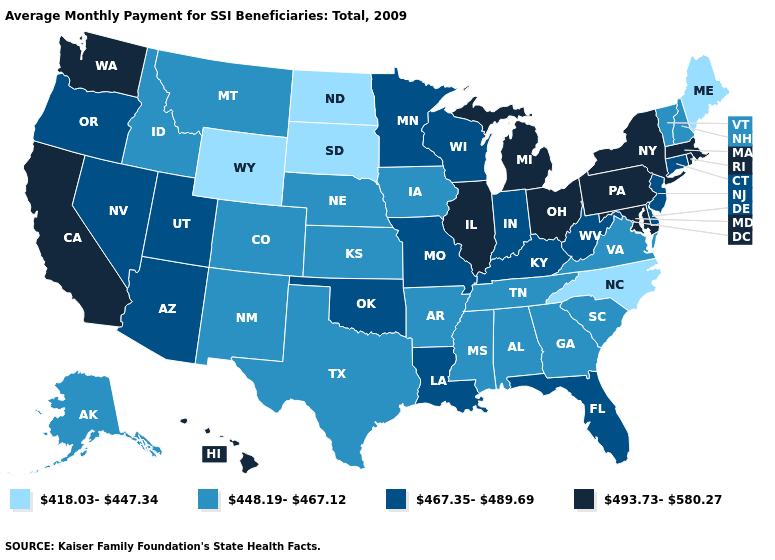Name the states that have a value in the range 418.03-447.34?
Give a very brief answer. Maine, North Carolina, North Dakota, South Dakota, Wyoming. Name the states that have a value in the range 448.19-467.12?
Answer briefly. Alabama, Alaska, Arkansas, Colorado, Georgia, Idaho, Iowa, Kansas, Mississippi, Montana, Nebraska, New Hampshire, New Mexico, South Carolina, Tennessee, Texas, Vermont, Virginia. What is the value of Maine?
Keep it brief. 418.03-447.34. What is the value of Alaska?
Quick response, please. 448.19-467.12. Among the states that border Arkansas , which have the lowest value?
Be succinct. Mississippi, Tennessee, Texas. Does the map have missing data?
Be succinct. No. Name the states that have a value in the range 493.73-580.27?
Give a very brief answer. California, Hawaii, Illinois, Maryland, Massachusetts, Michigan, New York, Ohio, Pennsylvania, Rhode Island, Washington. Name the states that have a value in the range 448.19-467.12?
Concise answer only. Alabama, Alaska, Arkansas, Colorado, Georgia, Idaho, Iowa, Kansas, Mississippi, Montana, Nebraska, New Hampshire, New Mexico, South Carolina, Tennessee, Texas, Vermont, Virginia. What is the value of Tennessee?
Be succinct. 448.19-467.12. Does Oklahoma have the same value as Minnesota?
Write a very short answer. Yes. Does Missouri have the same value as New Jersey?
Keep it brief. Yes. Does Wyoming have the same value as California?
Give a very brief answer. No. What is the highest value in states that border Nebraska?
Answer briefly. 467.35-489.69. Name the states that have a value in the range 448.19-467.12?
Quick response, please. Alabama, Alaska, Arkansas, Colorado, Georgia, Idaho, Iowa, Kansas, Mississippi, Montana, Nebraska, New Hampshire, New Mexico, South Carolina, Tennessee, Texas, Vermont, Virginia. Name the states that have a value in the range 418.03-447.34?
Answer briefly. Maine, North Carolina, North Dakota, South Dakota, Wyoming. 